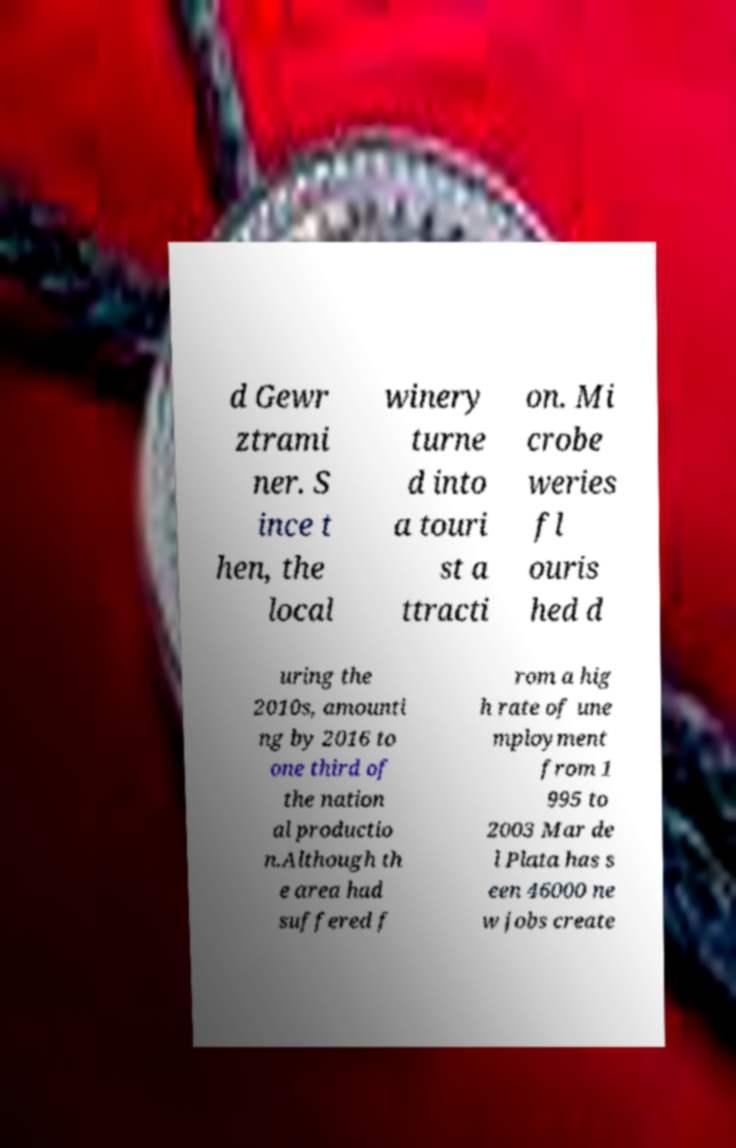Please identify and transcribe the text found in this image. d Gewr ztrami ner. S ince t hen, the local winery turne d into a touri st a ttracti on. Mi crobe weries fl ouris hed d uring the 2010s, amounti ng by 2016 to one third of the nation al productio n.Although th e area had suffered f rom a hig h rate of une mployment from 1 995 to 2003 Mar de l Plata has s een 46000 ne w jobs create 